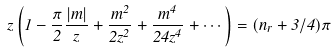Convert formula to latex. <formula><loc_0><loc_0><loc_500><loc_500>z \left ( 1 - \frac { \pi } { 2 } \frac { | m | } { z } + \frac { m ^ { 2 } } { 2 z ^ { 2 } } + \frac { m ^ { 4 } } { 2 4 z ^ { 4 } } + \cdots \right ) = ( n _ { r } + 3 / 4 ) \pi</formula> 